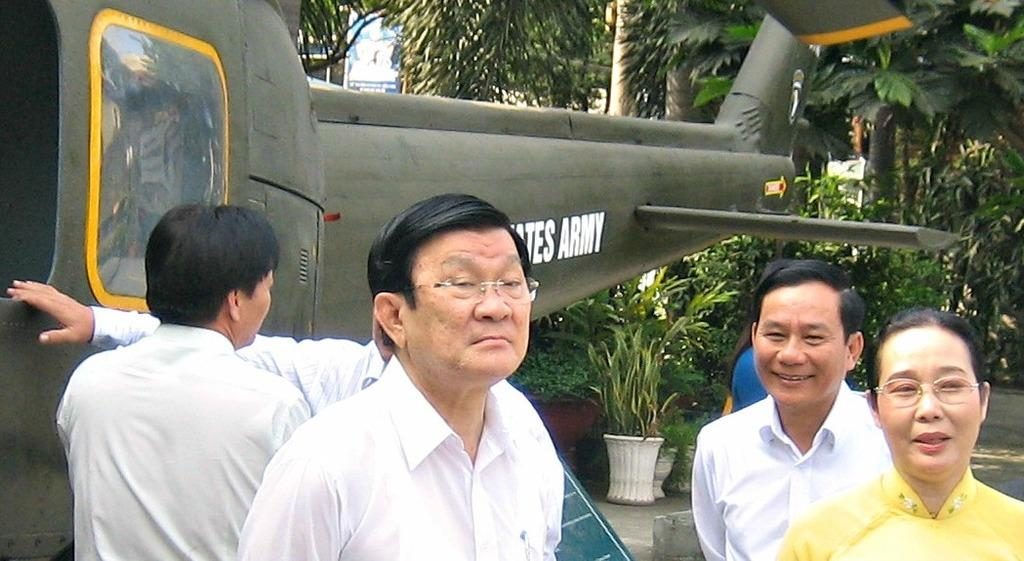<image>
Relay a brief, clear account of the picture shown. A group of people are standing outside an Army helicopter. 